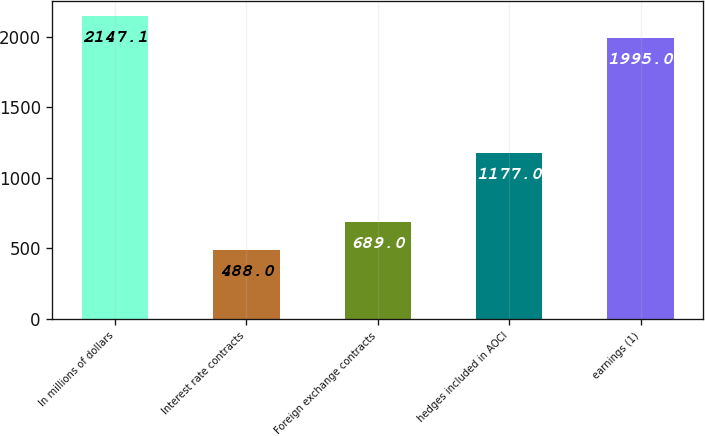Convert chart to OTSL. <chart><loc_0><loc_0><loc_500><loc_500><bar_chart><fcel>In millions of dollars<fcel>Interest rate contracts<fcel>Foreign exchange contracts<fcel>hedges included in AOCI<fcel>earnings (1)<nl><fcel>2147.1<fcel>488<fcel>689<fcel>1177<fcel>1995<nl></chart> 